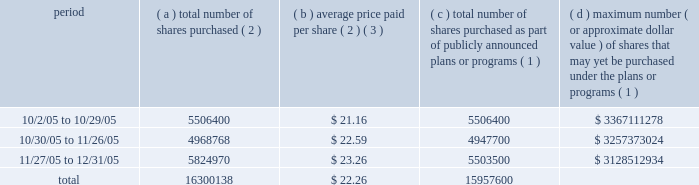Part ii item 5 : market for registrant's common equity , related stockholder matters and issuer purchases of equity securities motorola's common stock is listed on the new york and chicago stock exchanges .
The number of stockholders of record of motorola common stock on january 31 , 2006 was 80799 .
The remainder of the response to this item incorporates by reference note 15 , ""quarterly and other financial data ( unaudited ) '' of the notes to consolidated financial statements appearing under ""item 8 : financial statements and supplementary data'' .
The table provides information with respect to acquisitions by the company of shares of its common stock during the quarter ended december 31 , 2005 .
Issuer purchases of equity securities ( d ) maximum number ( c ) total number ( or approximate dollar of shares purchased value ) of shares that ( a ) total number ( b ) average price as part of publicly may yet be purchased of shares paid per announced plans under the plans or period purchased ( 2 ) share ( 2 ) ( 3 ) or programs ( 1 ) programs ( 1 ) .
( 1 ) on may 18 , 2005 , the company announced that its board of directors authorized the company to repurchase up to $ 4.0 billion of its outstanding shares of common stock over a 36-month period ending on may 31 , 2008 , subject to market conditions ( the ""stock repurchase program'' ) .
( 2 ) in addition to purchases under the stock repurchase program , included in this column are transactions under the company's equity compensation plans involving the delivery to the company of 342415 shares of motorola common stock to satisfy tax withholding obligations in connection with the vesting of restricted stock granted to company employees and the surrender of 123 shares of motorola common stock to pay the option exercise price in connection with the exercise of employee stock options .
( 3 ) average price paid per share of stock repurchased under the stock repurchase program is execution price , excluding commissions paid to brokers. .
Approximately how many shares can be purchased with the maximum amount given for the period between 10/2/05 and 10/29/05 , given the same average share price? 
Rationale: maximum number ( or approximate dollar value ) of shares that may yet be purchased under the plans or programs divided by the average price estimates the number of shares that can still be purchased
Computations: (3367111278 / 21.16)
Answer: 159126241.87146. Part ii item 5 : market for registrant's common equity , related stockholder matters and issuer purchases of equity securities motorola's common stock is listed on the new york and chicago stock exchanges .
The number of stockholders of record of motorola common stock on january 31 , 2006 was 80799 .
The remainder of the response to this item incorporates by reference note 15 , ""quarterly and other financial data ( unaudited ) '' of the notes to consolidated financial statements appearing under ""item 8 : financial statements and supplementary data'' .
The table provides information with respect to acquisitions by the company of shares of its common stock during the quarter ended december 31 , 2005 .
Issuer purchases of equity securities ( d ) maximum number ( c ) total number ( or approximate dollar of shares purchased value ) of shares that ( a ) total number ( b ) average price as part of publicly may yet be purchased of shares paid per announced plans under the plans or period purchased ( 2 ) share ( 2 ) ( 3 ) or programs ( 1 ) programs ( 1 ) .
( 1 ) on may 18 , 2005 , the company announced that its board of directors authorized the company to repurchase up to $ 4.0 billion of its outstanding shares of common stock over a 36-month period ending on may 31 , 2008 , subject to market conditions ( the ""stock repurchase program'' ) .
( 2 ) in addition to purchases under the stock repurchase program , included in this column are transactions under the company's equity compensation plans involving the delivery to the company of 342415 shares of motorola common stock to satisfy tax withholding obligations in connection with the vesting of restricted stock granted to company employees and the surrender of 123 shares of motorola common stock to pay the option exercise price in connection with the exercise of employee stock options .
( 3 ) average price paid per share of stock repurchased under the stock repurchase program is execution price , excluding commissions paid to brokers. .
What is the estimated value , in dollars , of the total number of shares purchased between 10/2/05 and 10/29/05? 
Computations: (5506400 * 21.16)
Answer: 116515424.0. Part ii item 5 : market for registrant's common equity , related stockholder matters and issuer purchases of equity securities motorola's common stock is listed on the new york and chicago stock exchanges .
The number of stockholders of record of motorola common stock on january 31 , 2006 was 80799 .
The remainder of the response to this item incorporates by reference note 15 , ""quarterly and other financial data ( unaudited ) '' of the notes to consolidated financial statements appearing under ""item 8 : financial statements and supplementary data'' .
The table provides information with respect to acquisitions by the company of shares of its common stock during the quarter ended december 31 , 2005 .
Issuer purchases of equity securities ( d ) maximum number ( c ) total number ( or approximate dollar of shares purchased value ) of shares that ( a ) total number ( b ) average price as part of publicly may yet be purchased of shares paid per announced plans under the plans or period purchased ( 2 ) share ( 2 ) ( 3 ) or programs ( 1 ) programs ( 1 ) .
( 1 ) on may 18 , 2005 , the company announced that its board of directors authorized the company to repurchase up to $ 4.0 billion of its outstanding shares of common stock over a 36-month period ending on may 31 , 2008 , subject to market conditions ( the ""stock repurchase program'' ) .
( 2 ) in addition to purchases under the stock repurchase program , included in this column are transactions under the company's equity compensation plans involving the delivery to the company of 342415 shares of motorola common stock to satisfy tax withholding obligations in connection with the vesting of restricted stock granted to company employees and the surrender of 123 shares of motorola common stock to pay the option exercise price in connection with the exercise of employee stock options .
( 3 ) average price paid per share of stock repurchased under the stock repurchase program is execution price , excluding commissions paid to brokers. .
In 2005 what was the percent of the total number of shares purchased as part of publicly announced plans or programs on or after 11/25/2005? 
Computations: (5503500 / 15957600)
Answer: 0.34488. 